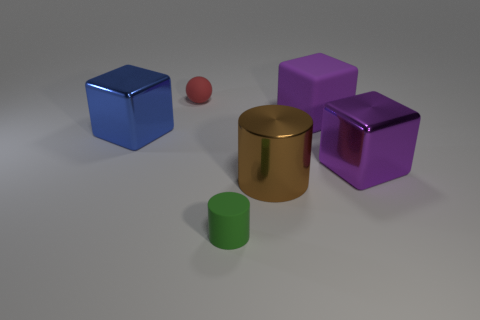Can you describe the texture on the surfaces of the objects? Certainly. The objects appear to have relatively smooth surfaces with subtle textures that suggest a matte finish. The lighting creates soft reflections, indicating that the surfaces are not highly glossy but might have a slight sheen. 